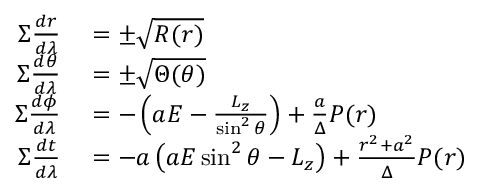<formula> <loc_0><loc_0><loc_500><loc_500>\begin{array} { r l } { \Sigma { \frac { d r } { d \lambda } } } & = \pm { \sqrt { R ( r ) } } } \\ { \Sigma { \frac { d \theta } { d \lambda } } } & = \pm { \sqrt { \Theta ( \theta ) } } } \\ { \Sigma { \frac { d \phi } { d \lambda } } } & = - \left ( a E - { \frac { L _ { z } } { \sin ^ { 2 } \theta } } \right ) + { \frac { a } { \Delta } } P ( r ) } \\ { \Sigma { \frac { d t } { d \lambda } } } & = - a \left ( a E \sin ^ { 2 } \theta - L _ { z } \right ) + { \frac { r ^ { 2 } + a ^ { 2 } } { \Delta } } P ( r ) } \end{array}</formula> 